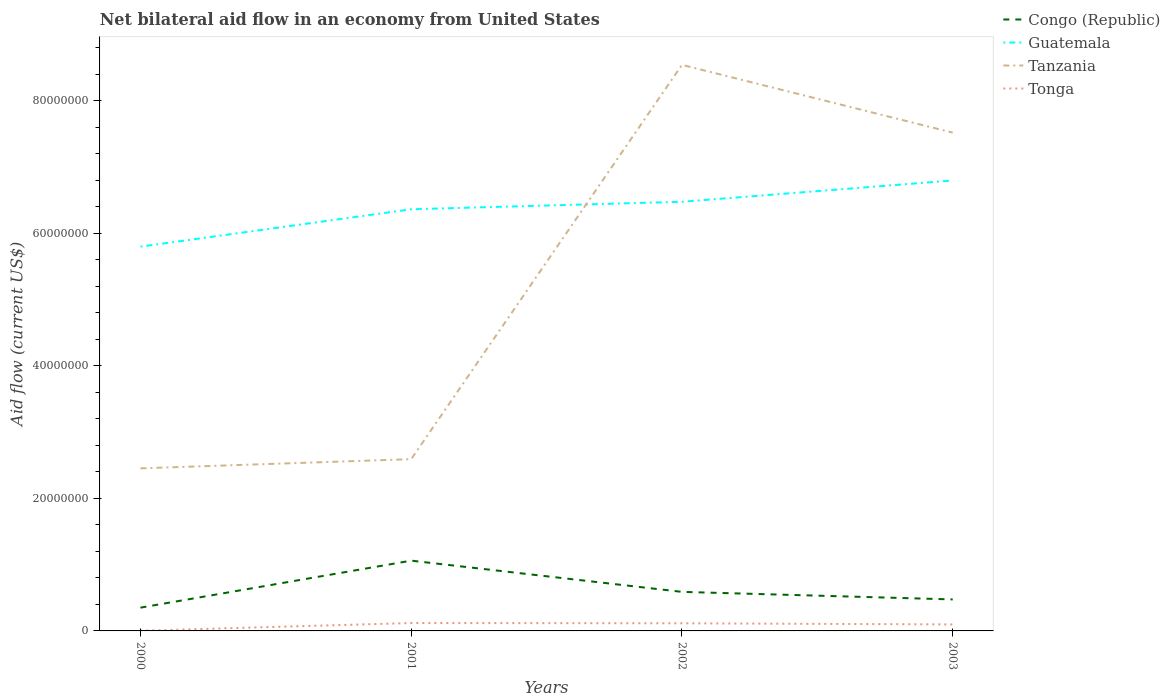How many different coloured lines are there?
Your answer should be very brief. 4. Does the line corresponding to Guatemala intersect with the line corresponding to Congo (Republic)?
Provide a short and direct response. No. Across all years, what is the maximum net bilateral aid flow in Congo (Republic)?
Offer a very short reply. 3.51e+06. What is the total net bilateral aid flow in Guatemala in the graph?
Ensure brevity in your answer.  -9.98e+06. What is the difference between the highest and the second highest net bilateral aid flow in Tonga?
Give a very brief answer. 1.16e+06. Is the net bilateral aid flow in Guatemala strictly greater than the net bilateral aid flow in Congo (Republic) over the years?
Offer a very short reply. No. Does the graph contain any zero values?
Keep it short and to the point. No. Does the graph contain grids?
Your answer should be compact. No. Where does the legend appear in the graph?
Offer a terse response. Top right. How many legend labels are there?
Your answer should be very brief. 4. How are the legend labels stacked?
Ensure brevity in your answer.  Vertical. What is the title of the graph?
Your answer should be compact. Net bilateral aid flow in an economy from United States. What is the label or title of the X-axis?
Provide a succinct answer. Years. What is the label or title of the Y-axis?
Make the answer very short. Aid flow (current US$). What is the Aid flow (current US$) of Congo (Republic) in 2000?
Your response must be concise. 3.51e+06. What is the Aid flow (current US$) of Guatemala in 2000?
Your answer should be very brief. 5.80e+07. What is the Aid flow (current US$) in Tanzania in 2000?
Ensure brevity in your answer.  2.45e+07. What is the Aid flow (current US$) of Congo (Republic) in 2001?
Make the answer very short. 1.06e+07. What is the Aid flow (current US$) in Guatemala in 2001?
Offer a very short reply. 6.36e+07. What is the Aid flow (current US$) in Tanzania in 2001?
Provide a succinct answer. 2.59e+07. What is the Aid flow (current US$) of Tonga in 2001?
Offer a terse response. 1.19e+06. What is the Aid flow (current US$) in Congo (Republic) in 2002?
Your answer should be compact. 5.89e+06. What is the Aid flow (current US$) in Guatemala in 2002?
Offer a very short reply. 6.47e+07. What is the Aid flow (current US$) in Tanzania in 2002?
Offer a terse response. 8.54e+07. What is the Aid flow (current US$) in Tonga in 2002?
Provide a short and direct response. 1.15e+06. What is the Aid flow (current US$) of Congo (Republic) in 2003?
Your answer should be very brief. 4.75e+06. What is the Aid flow (current US$) in Guatemala in 2003?
Offer a terse response. 6.79e+07. What is the Aid flow (current US$) in Tanzania in 2003?
Your answer should be very brief. 7.52e+07. What is the Aid flow (current US$) of Tonga in 2003?
Provide a short and direct response. 9.80e+05. Across all years, what is the maximum Aid flow (current US$) in Congo (Republic)?
Keep it short and to the point. 1.06e+07. Across all years, what is the maximum Aid flow (current US$) of Guatemala?
Keep it short and to the point. 6.79e+07. Across all years, what is the maximum Aid flow (current US$) in Tanzania?
Provide a succinct answer. 8.54e+07. Across all years, what is the maximum Aid flow (current US$) in Tonga?
Ensure brevity in your answer.  1.19e+06. Across all years, what is the minimum Aid flow (current US$) in Congo (Republic)?
Provide a succinct answer. 3.51e+06. Across all years, what is the minimum Aid flow (current US$) of Guatemala?
Your response must be concise. 5.80e+07. Across all years, what is the minimum Aid flow (current US$) of Tanzania?
Your response must be concise. 2.45e+07. Across all years, what is the minimum Aid flow (current US$) of Tonga?
Give a very brief answer. 3.00e+04. What is the total Aid flow (current US$) of Congo (Republic) in the graph?
Offer a terse response. 2.48e+07. What is the total Aid flow (current US$) in Guatemala in the graph?
Make the answer very short. 2.54e+08. What is the total Aid flow (current US$) in Tanzania in the graph?
Your response must be concise. 2.11e+08. What is the total Aid flow (current US$) of Tonga in the graph?
Ensure brevity in your answer.  3.35e+06. What is the difference between the Aid flow (current US$) of Congo (Republic) in 2000 and that in 2001?
Offer a very short reply. -7.09e+06. What is the difference between the Aid flow (current US$) of Guatemala in 2000 and that in 2001?
Your response must be concise. -5.64e+06. What is the difference between the Aid flow (current US$) in Tanzania in 2000 and that in 2001?
Provide a short and direct response. -1.39e+06. What is the difference between the Aid flow (current US$) of Tonga in 2000 and that in 2001?
Ensure brevity in your answer.  -1.16e+06. What is the difference between the Aid flow (current US$) in Congo (Republic) in 2000 and that in 2002?
Offer a terse response. -2.38e+06. What is the difference between the Aid flow (current US$) of Guatemala in 2000 and that in 2002?
Keep it short and to the point. -6.77e+06. What is the difference between the Aid flow (current US$) in Tanzania in 2000 and that in 2002?
Make the answer very short. -6.09e+07. What is the difference between the Aid flow (current US$) of Tonga in 2000 and that in 2002?
Give a very brief answer. -1.12e+06. What is the difference between the Aid flow (current US$) of Congo (Republic) in 2000 and that in 2003?
Give a very brief answer. -1.24e+06. What is the difference between the Aid flow (current US$) of Guatemala in 2000 and that in 2003?
Ensure brevity in your answer.  -9.98e+06. What is the difference between the Aid flow (current US$) of Tanzania in 2000 and that in 2003?
Make the answer very short. -5.06e+07. What is the difference between the Aid flow (current US$) of Tonga in 2000 and that in 2003?
Ensure brevity in your answer.  -9.50e+05. What is the difference between the Aid flow (current US$) in Congo (Republic) in 2001 and that in 2002?
Offer a very short reply. 4.71e+06. What is the difference between the Aid flow (current US$) in Guatemala in 2001 and that in 2002?
Give a very brief answer. -1.13e+06. What is the difference between the Aid flow (current US$) in Tanzania in 2001 and that in 2002?
Keep it short and to the point. -5.95e+07. What is the difference between the Aid flow (current US$) of Tonga in 2001 and that in 2002?
Your answer should be very brief. 4.00e+04. What is the difference between the Aid flow (current US$) of Congo (Republic) in 2001 and that in 2003?
Ensure brevity in your answer.  5.85e+06. What is the difference between the Aid flow (current US$) of Guatemala in 2001 and that in 2003?
Your answer should be very brief. -4.34e+06. What is the difference between the Aid flow (current US$) of Tanzania in 2001 and that in 2003?
Your answer should be compact. -4.92e+07. What is the difference between the Aid flow (current US$) of Tonga in 2001 and that in 2003?
Your answer should be very brief. 2.10e+05. What is the difference between the Aid flow (current US$) in Congo (Republic) in 2002 and that in 2003?
Ensure brevity in your answer.  1.14e+06. What is the difference between the Aid flow (current US$) in Guatemala in 2002 and that in 2003?
Keep it short and to the point. -3.21e+06. What is the difference between the Aid flow (current US$) of Tanzania in 2002 and that in 2003?
Ensure brevity in your answer.  1.02e+07. What is the difference between the Aid flow (current US$) of Tonga in 2002 and that in 2003?
Provide a short and direct response. 1.70e+05. What is the difference between the Aid flow (current US$) in Congo (Republic) in 2000 and the Aid flow (current US$) in Guatemala in 2001?
Give a very brief answer. -6.01e+07. What is the difference between the Aid flow (current US$) in Congo (Republic) in 2000 and the Aid flow (current US$) in Tanzania in 2001?
Provide a succinct answer. -2.24e+07. What is the difference between the Aid flow (current US$) in Congo (Republic) in 2000 and the Aid flow (current US$) in Tonga in 2001?
Provide a short and direct response. 2.32e+06. What is the difference between the Aid flow (current US$) of Guatemala in 2000 and the Aid flow (current US$) of Tanzania in 2001?
Offer a very short reply. 3.20e+07. What is the difference between the Aid flow (current US$) of Guatemala in 2000 and the Aid flow (current US$) of Tonga in 2001?
Provide a succinct answer. 5.68e+07. What is the difference between the Aid flow (current US$) in Tanzania in 2000 and the Aid flow (current US$) in Tonga in 2001?
Provide a short and direct response. 2.33e+07. What is the difference between the Aid flow (current US$) in Congo (Republic) in 2000 and the Aid flow (current US$) in Guatemala in 2002?
Keep it short and to the point. -6.12e+07. What is the difference between the Aid flow (current US$) of Congo (Republic) in 2000 and the Aid flow (current US$) of Tanzania in 2002?
Your answer should be very brief. -8.19e+07. What is the difference between the Aid flow (current US$) of Congo (Republic) in 2000 and the Aid flow (current US$) of Tonga in 2002?
Keep it short and to the point. 2.36e+06. What is the difference between the Aid flow (current US$) of Guatemala in 2000 and the Aid flow (current US$) of Tanzania in 2002?
Your answer should be very brief. -2.74e+07. What is the difference between the Aid flow (current US$) of Guatemala in 2000 and the Aid flow (current US$) of Tonga in 2002?
Offer a terse response. 5.68e+07. What is the difference between the Aid flow (current US$) in Tanzania in 2000 and the Aid flow (current US$) in Tonga in 2002?
Offer a terse response. 2.34e+07. What is the difference between the Aid flow (current US$) of Congo (Republic) in 2000 and the Aid flow (current US$) of Guatemala in 2003?
Offer a very short reply. -6.44e+07. What is the difference between the Aid flow (current US$) in Congo (Republic) in 2000 and the Aid flow (current US$) in Tanzania in 2003?
Your response must be concise. -7.16e+07. What is the difference between the Aid flow (current US$) in Congo (Republic) in 2000 and the Aid flow (current US$) in Tonga in 2003?
Provide a short and direct response. 2.53e+06. What is the difference between the Aid flow (current US$) in Guatemala in 2000 and the Aid flow (current US$) in Tanzania in 2003?
Make the answer very short. -1.72e+07. What is the difference between the Aid flow (current US$) in Guatemala in 2000 and the Aid flow (current US$) in Tonga in 2003?
Your answer should be compact. 5.70e+07. What is the difference between the Aid flow (current US$) of Tanzania in 2000 and the Aid flow (current US$) of Tonga in 2003?
Your answer should be very brief. 2.35e+07. What is the difference between the Aid flow (current US$) in Congo (Republic) in 2001 and the Aid flow (current US$) in Guatemala in 2002?
Make the answer very short. -5.41e+07. What is the difference between the Aid flow (current US$) in Congo (Republic) in 2001 and the Aid flow (current US$) in Tanzania in 2002?
Provide a short and direct response. -7.48e+07. What is the difference between the Aid flow (current US$) in Congo (Republic) in 2001 and the Aid flow (current US$) in Tonga in 2002?
Ensure brevity in your answer.  9.45e+06. What is the difference between the Aid flow (current US$) in Guatemala in 2001 and the Aid flow (current US$) in Tanzania in 2002?
Your response must be concise. -2.18e+07. What is the difference between the Aid flow (current US$) in Guatemala in 2001 and the Aid flow (current US$) in Tonga in 2002?
Offer a terse response. 6.24e+07. What is the difference between the Aid flow (current US$) of Tanzania in 2001 and the Aid flow (current US$) of Tonga in 2002?
Give a very brief answer. 2.48e+07. What is the difference between the Aid flow (current US$) in Congo (Republic) in 2001 and the Aid flow (current US$) in Guatemala in 2003?
Keep it short and to the point. -5.73e+07. What is the difference between the Aid flow (current US$) of Congo (Republic) in 2001 and the Aid flow (current US$) of Tanzania in 2003?
Your response must be concise. -6.46e+07. What is the difference between the Aid flow (current US$) of Congo (Republic) in 2001 and the Aid flow (current US$) of Tonga in 2003?
Provide a short and direct response. 9.62e+06. What is the difference between the Aid flow (current US$) in Guatemala in 2001 and the Aid flow (current US$) in Tanzania in 2003?
Your answer should be very brief. -1.16e+07. What is the difference between the Aid flow (current US$) in Guatemala in 2001 and the Aid flow (current US$) in Tonga in 2003?
Ensure brevity in your answer.  6.26e+07. What is the difference between the Aid flow (current US$) in Tanzania in 2001 and the Aid flow (current US$) in Tonga in 2003?
Offer a terse response. 2.49e+07. What is the difference between the Aid flow (current US$) in Congo (Republic) in 2002 and the Aid flow (current US$) in Guatemala in 2003?
Provide a short and direct response. -6.20e+07. What is the difference between the Aid flow (current US$) in Congo (Republic) in 2002 and the Aid flow (current US$) in Tanzania in 2003?
Ensure brevity in your answer.  -6.93e+07. What is the difference between the Aid flow (current US$) of Congo (Republic) in 2002 and the Aid flow (current US$) of Tonga in 2003?
Provide a succinct answer. 4.91e+06. What is the difference between the Aid flow (current US$) of Guatemala in 2002 and the Aid flow (current US$) of Tanzania in 2003?
Make the answer very short. -1.04e+07. What is the difference between the Aid flow (current US$) of Guatemala in 2002 and the Aid flow (current US$) of Tonga in 2003?
Provide a succinct answer. 6.38e+07. What is the difference between the Aid flow (current US$) of Tanzania in 2002 and the Aid flow (current US$) of Tonga in 2003?
Offer a terse response. 8.44e+07. What is the average Aid flow (current US$) of Congo (Republic) per year?
Make the answer very short. 6.19e+06. What is the average Aid flow (current US$) of Guatemala per year?
Provide a succinct answer. 6.36e+07. What is the average Aid flow (current US$) in Tanzania per year?
Your answer should be very brief. 5.27e+07. What is the average Aid flow (current US$) in Tonga per year?
Give a very brief answer. 8.38e+05. In the year 2000, what is the difference between the Aid flow (current US$) in Congo (Republic) and Aid flow (current US$) in Guatemala?
Your answer should be very brief. -5.44e+07. In the year 2000, what is the difference between the Aid flow (current US$) of Congo (Republic) and Aid flow (current US$) of Tanzania?
Your answer should be very brief. -2.10e+07. In the year 2000, what is the difference between the Aid flow (current US$) of Congo (Republic) and Aid flow (current US$) of Tonga?
Offer a very short reply. 3.48e+06. In the year 2000, what is the difference between the Aid flow (current US$) in Guatemala and Aid flow (current US$) in Tanzania?
Your answer should be compact. 3.34e+07. In the year 2000, what is the difference between the Aid flow (current US$) in Guatemala and Aid flow (current US$) in Tonga?
Provide a succinct answer. 5.79e+07. In the year 2000, what is the difference between the Aid flow (current US$) of Tanzania and Aid flow (current US$) of Tonga?
Your answer should be compact. 2.45e+07. In the year 2001, what is the difference between the Aid flow (current US$) in Congo (Republic) and Aid flow (current US$) in Guatemala?
Ensure brevity in your answer.  -5.30e+07. In the year 2001, what is the difference between the Aid flow (current US$) in Congo (Republic) and Aid flow (current US$) in Tanzania?
Offer a very short reply. -1.53e+07. In the year 2001, what is the difference between the Aid flow (current US$) in Congo (Republic) and Aid flow (current US$) in Tonga?
Ensure brevity in your answer.  9.41e+06. In the year 2001, what is the difference between the Aid flow (current US$) of Guatemala and Aid flow (current US$) of Tanzania?
Keep it short and to the point. 3.77e+07. In the year 2001, what is the difference between the Aid flow (current US$) in Guatemala and Aid flow (current US$) in Tonga?
Give a very brief answer. 6.24e+07. In the year 2001, what is the difference between the Aid flow (current US$) in Tanzania and Aid flow (current US$) in Tonga?
Provide a short and direct response. 2.47e+07. In the year 2002, what is the difference between the Aid flow (current US$) in Congo (Republic) and Aid flow (current US$) in Guatemala?
Make the answer very short. -5.88e+07. In the year 2002, what is the difference between the Aid flow (current US$) of Congo (Republic) and Aid flow (current US$) of Tanzania?
Your response must be concise. -7.95e+07. In the year 2002, what is the difference between the Aid flow (current US$) of Congo (Republic) and Aid flow (current US$) of Tonga?
Provide a succinct answer. 4.74e+06. In the year 2002, what is the difference between the Aid flow (current US$) of Guatemala and Aid flow (current US$) of Tanzania?
Offer a very short reply. -2.06e+07. In the year 2002, what is the difference between the Aid flow (current US$) of Guatemala and Aid flow (current US$) of Tonga?
Keep it short and to the point. 6.36e+07. In the year 2002, what is the difference between the Aid flow (current US$) of Tanzania and Aid flow (current US$) of Tonga?
Your response must be concise. 8.42e+07. In the year 2003, what is the difference between the Aid flow (current US$) in Congo (Republic) and Aid flow (current US$) in Guatemala?
Your response must be concise. -6.32e+07. In the year 2003, what is the difference between the Aid flow (current US$) of Congo (Republic) and Aid flow (current US$) of Tanzania?
Make the answer very short. -7.04e+07. In the year 2003, what is the difference between the Aid flow (current US$) in Congo (Republic) and Aid flow (current US$) in Tonga?
Ensure brevity in your answer.  3.77e+06. In the year 2003, what is the difference between the Aid flow (current US$) of Guatemala and Aid flow (current US$) of Tanzania?
Offer a very short reply. -7.22e+06. In the year 2003, what is the difference between the Aid flow (current US$) of Guatemala and Aid flow (current US$) of Tonga?
Your answer should be compact. 6.70e+07. In the year 2003, what is the difference between the Aid flow (current US$) in Tanzania and Aid flow (current US$) in Tonga?
Provide a succinct answer. 7.42e+07. What is the ratio of the Aid flow (current US$) of Congo (Republic) in 2000 to that in 2001?
Offer a very short reply. 0.33. What is the ratio of the Aid flow (current US$) of Guatemala in 2000 to that in 2001?
Offer a terse response. 0.91. What is the ratio of the Aid flow (current US$) of Tanzania in 2000 to that in 2001?
Keep it short and to the point. 0.95. What is the ratio of the Aid flow (current US$) of Tonga in 2000 to that in 2001?
Offer a very short reply. 0.03. What is the ratio of the Aid flow (current US$) of Congo (Republic) in 2000 to that in 2002?
Give a very brief answer. 0.6. What is the ratio of the Aid flow (current US$) of Guatemala in 2000 to that in 2002?
Ensure brevity in your answer.  0.9. What is the ratio of the Aid flow (current US$) of Tanzania in 2000 to that in 2002?
Your response must be concise. 0.29. What is the ratio of the Aid flow (current US$) in Tonga in 2000 to that in 2002?
Make the answer very short. 0.03. What is the ratio of the Aid flow (current US$) of Congo (Republic) in 2000 to that in 2003?
Provide a short and direct response. 0.74. What is the ratio of the Aid flow (current US$) in Guatemala in 2000 to that in 2003?
Your response must be concise. 0.85. What is the ratio of the Aid flow (current US$) in Tanzania in 2000 to that in 2003?
Your answer should be very brief. 0.33. What is the ratio of the Aid flow (current US$) in Tonga in 2000 to that in 2003?
Your answer should be very brief. 0.03. What is the ratio of the Aid flow (current US$) of Congo (Republic) in 2001 to that in 2002?
Provide a succinct answer. 1.8. What is the ratio of the Aid flow (current US$) in Guatemala in 2001 to that in 2002?
Keep it short and to the point. 0.98. What is the ratio of the Aid flow (current US$) of Tanzania in 2001 to that in 2002?
Offer a very short reply. 0.3. What is the ratio of the Aid flow (current US$) in Tonga in 2001 to that in 2002?
Provide a succinct answer. 1.03. What is the ratio of the Aid flow (current US$) of Congo (Republic) in 2001 to that in 2003?
Your answer should be very brief. 2.23. What is the ratio of the Aid flow (current US$) of Guatemala in 2001 to that in 2003?
Make the answer very short. 0.94. What is the ratio of the Aid flow (current US$) of Tanzania in 2001 to that in 2003?
Your answer should be very brief. 0.34. What is the ratio of the Aid flow (current US$) in Tonga in 2001 to that in 2003?
Offer a terse response. 1.21. What is the ratio of the Aid flow (current US$) in Congo (Republic) in 2002 to that in 2003?
Keep it short and to the point. 1.24. What is the ratio of the Aid flow (current US$) of Guatemala in 2002 to that in 2003?
Your response must be concise. 0.95. What is the ratio of the Aid flow (current US$) in Tanzania in 2002 to that in 2003?
Ensure brevity in your answer.  1.14. What is the ratio of the Aid flow (current US$) of Tonga in 2002 to that in 2003?
Your response must be concise. 1.17. What is the difference between the highest and the second highest Aid flow (current US$) of Congo (Republic)?
Keep it short and to the point. 4.71e+06. What is the difference between the highest and the second highest Aid flow (current US$) of Guatemala?
Your answer should be very brief. 3.21e+06. What is the difference between the highest and the second highest Aid flow (current US$) in Tanzania?
Provide a short and direct response. 1.02e+07. What is the difference between the highest and the lowest Aid flow (current US$) of Congo (Republic)?
Provide a short and direct response. 7.09e+06. What is the difference between the highest and the lowest Aid flow (current US$) of Guatemala?
Offer a very short reply. 9.98e+06. What is the difference between the highest and the lowest Aid flow (current US$) in Tanzania?
Provide a succinct answer. 6.09e+07. What is the difference between the highest and the lowest Aid flow (current US$) in Tonga?
Offer a very short reply. 1.16e+06. 